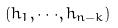Convert formula to latex. <formula><loc_0><loc_0><loc_500><loc_500>( h _ { 1 } , \cdot \cdot \cdot , h _ { n - k } )</formula> 